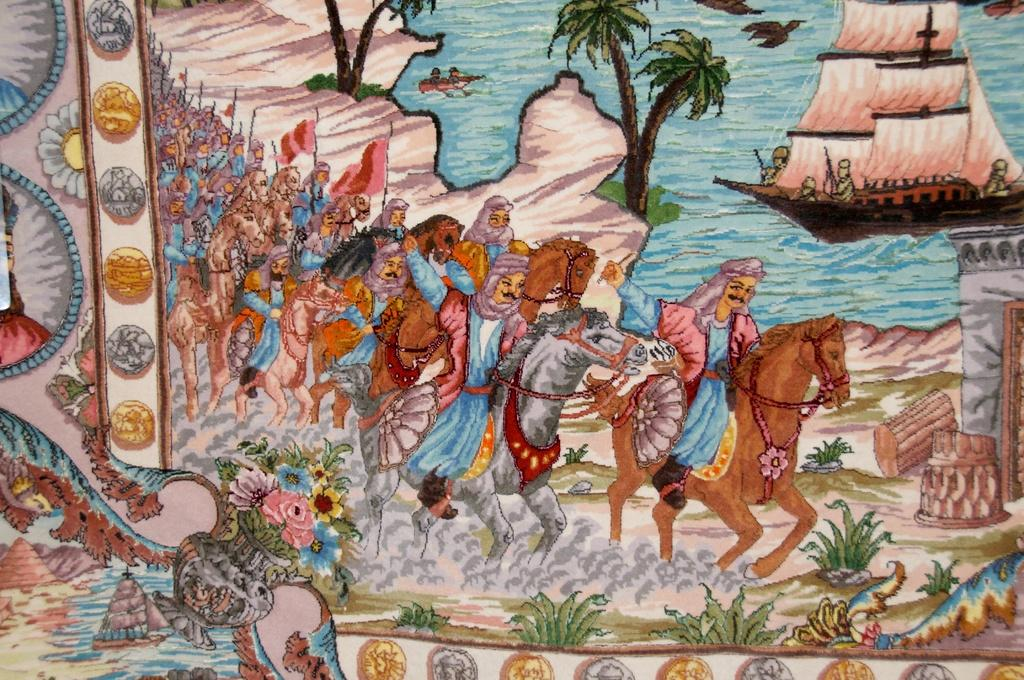What is the primary subject matter of the painting? The painting contains many trees, a sea, and a watercraft, suggesting a landscape or seascape. Are there any living beings depicted in the painting? Yes, the painting features many people and horses. What type of activity might be taking place in the painting? The presence of weapons suggests that there may be some form of conflict or battle taking place. How many times does the person in the painting sneeze? There is no person depicted in the painting, and therefore no sneezing can be observed. What type of wound can be seen on the horse in the painting? There are no wounds visible on any of the horses in the painting. 